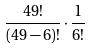<formula> <loc_0><loc_0><loc_500><loc_500>\frac { 4 9 ! } { ( 4 9 - 6 ) ! } \cdot \frac { 1 } { 6 ! }</formula> 